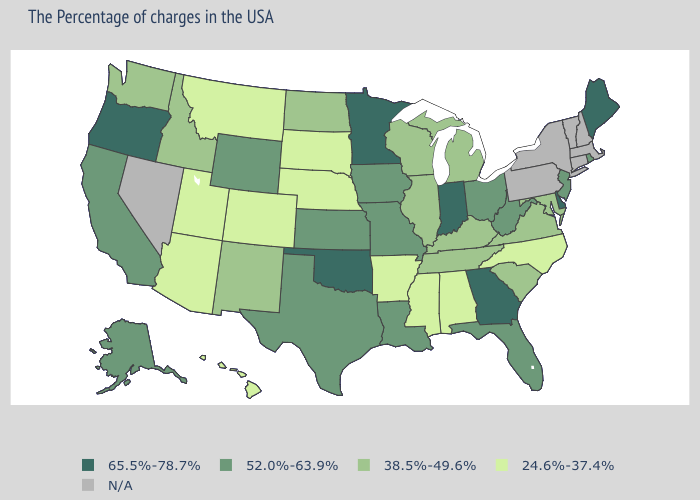Name the states that have a value in the range 65.5%-78.7%?
Concise answer only. Maine, Delaware, Georgia, Indiana, Minnesota, Oklahoma, Oregon. What is the lowest value in the South?
Give a very brief answer. 24.6%-37.4%. How many symbols are there in the legend?
Write a very short answer. 5. Name the states that have a value in the range 65.5%-78.7%?
Give a very brief answer. Maine, Delaware, Georgia, Indiana, Minnesota, Oklahoma, Oregon. What is the value of New Jersey?
Short answer required. 52.0%-63.9%. Does the map have missing data?
Short answer required. Yes. Name the states that have a value in the range N/A?
Quick response, please. Massachusetts, New Hampshire, Vermont, Connecticut, New York, Pennsylvania, Nevada. How many symbols are there in the legend?
Give a very brief answer. 5. What is the highest value in states that border Washington?
Keep it brief. 65.5%-78.7%. What is the value of Oregon?
Quick response, please. 65.5%-78.7%. Which states have the lowest value in the USA?
Write a very short answer. North Carolina, Alabama, Mississippi, Arkansas, Nebraska, South Dakota, Colorado, Utah, Montana, Arizona, Hawaii. Among the states that border Virginia , which have the highest value?
Quick response, please. West Virginia. Name the states that have a value in the range 65.5%-78.7%?
Answer briefly. Maine, Delaware, Georgia, Indiana, Minnesota, Oklahoma, Oregon. Does the first symbol in the legend represent the smallest category?
Concise answer only. No. 